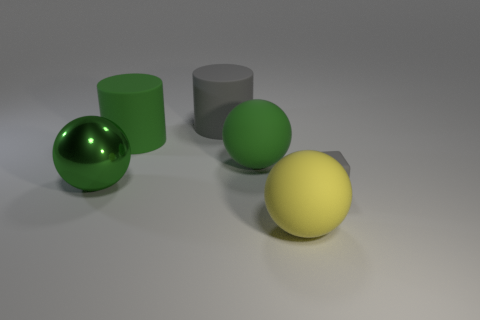Add 1 green matte cylinders. How many objects exist? 7 Subtract all cylinders. How many objects are left? 4 Add 4 metal things. How many metal things are left? 5 Add 6 large purple rubber balls. How many large purple rubber balls exist? 6 Subtract 0 cyan balls. How many objects are left? 6 Subtract all tiny yellow things. Subtract all large yellow rubber things. How many objects are left? 5 